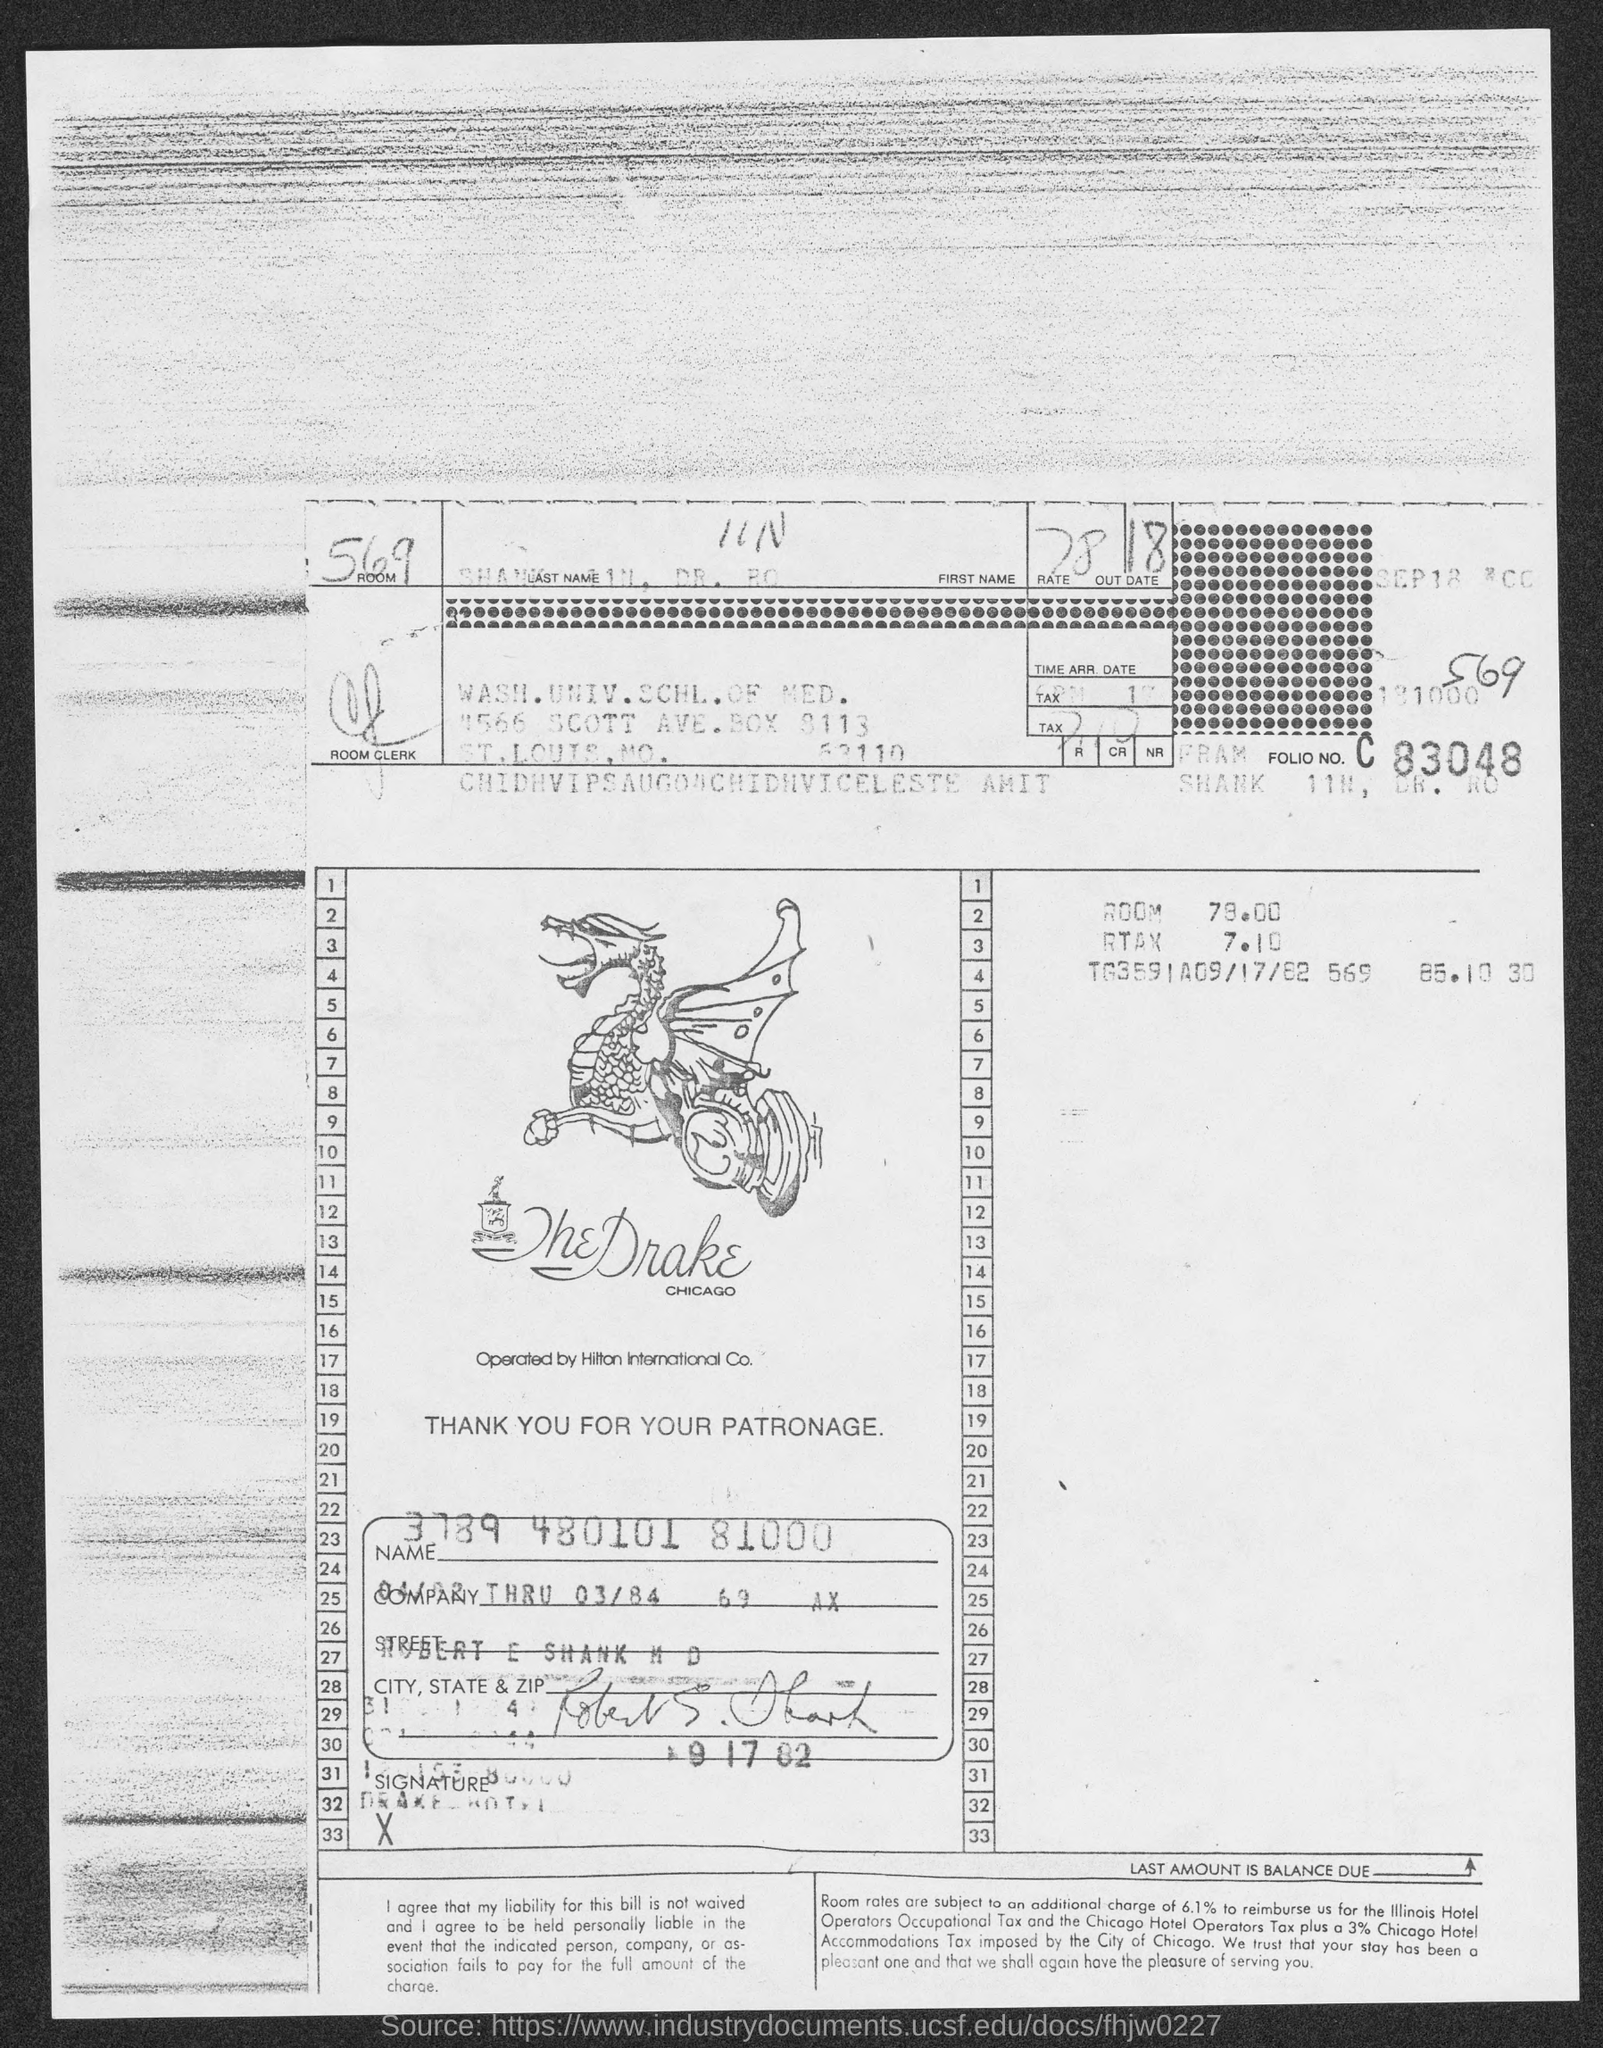Give some essential details in this illustration. Washington University School of Medicine is located in St. Louis County. The room number is 569. 